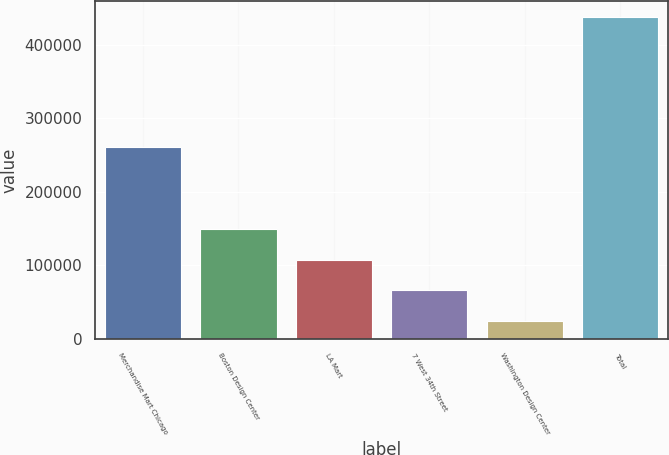<chart> <loc_0><loc_0><loc_500><loc_500><bar_chart><fcel>Merchandise Mart Chicago<fcel>Boston Design Center<fcel>LA Mart<fcel>7 West 34th Street<fcel>Washington Design Center<fcel>Total<nl><fcel>261000<fcel>148900<fcel>107600<fcel>66300<fcel>25000<fcel>438000<nl></chart> 